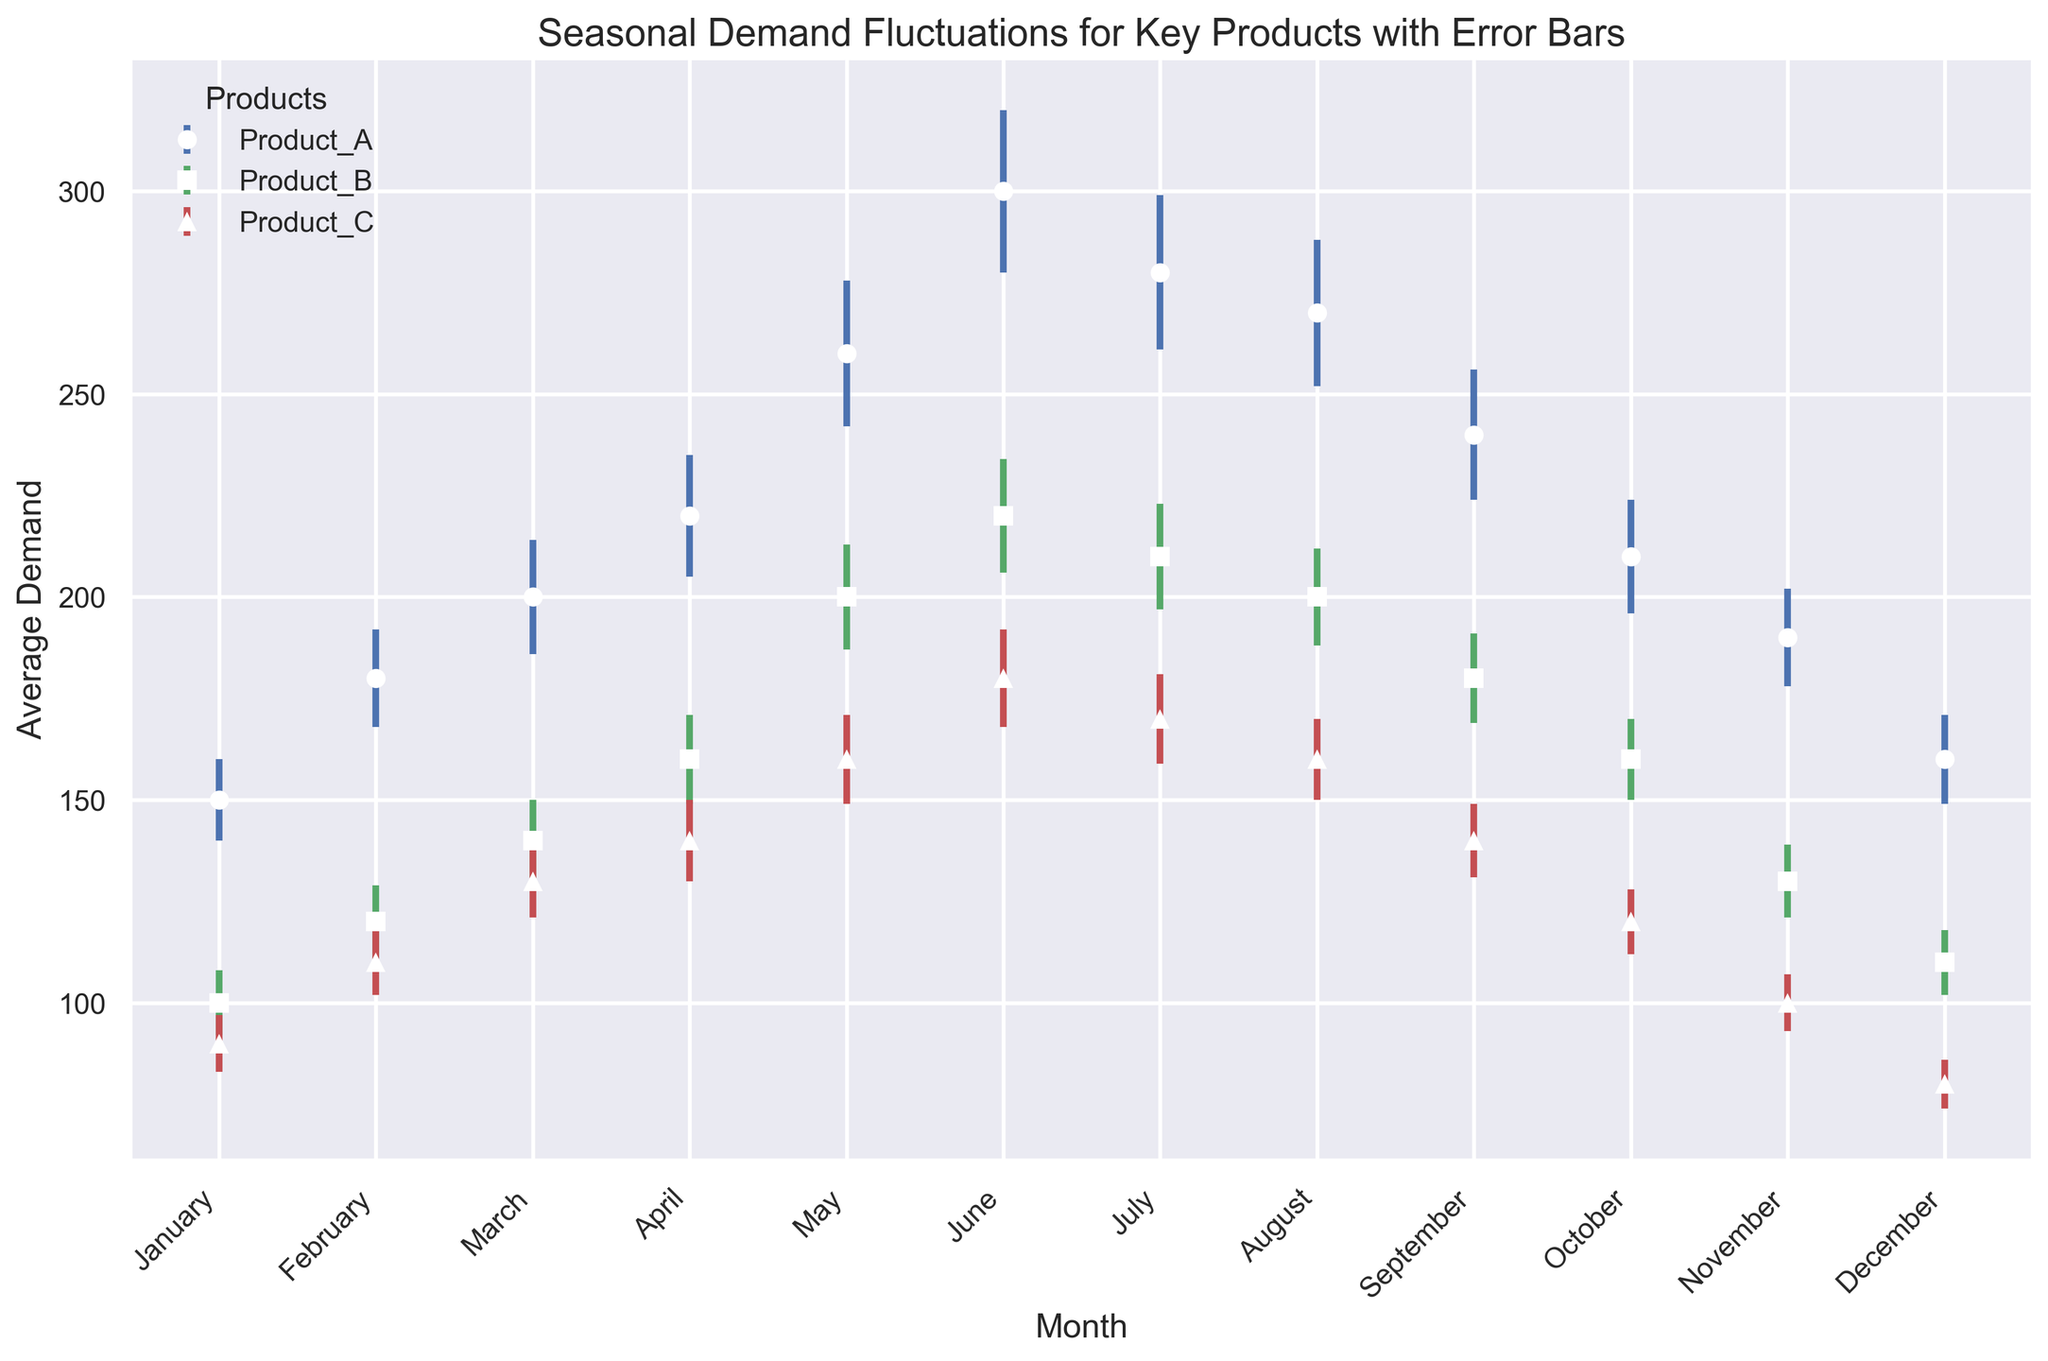Which product has the highest peak demand, and in which month does it occur? Observing the plot, Product_A peaks at 300 units in June, which is the highest among all products.
Answer: Product_A in June What is the difference in average demand between Product_B and Product_C in July? In July, Product_B has an average demand of 210 units, and Product_C has 170 units. The difference is 210 - 170 = 40 units.
Answer: 40 units Between which two consecutive months does Product_A show the largest decrease in demand? Between June and July, Product_A's demand decreases from 300 to 280 units, a drop of 20 units, which is the largest observed decrease.
Answer: June to July Which product shows the most consistent demand throughout the year, based on visually smallest error bars? Visually, Product_C has the smallest error bars throughout most months, indicating consistent demand.
Answer: Product_C In which month does Product_B have the lowest average demand, and what is it? Observing the plot, Product_B has the lowest demand of 100 units in January.
Answer: January with 100 units What is the average demand for Product_A over the entire year? Sum the average demand for each month for Product_A: (150 + 180 + 200 + 220 + 260 + 300 + 280 + 270 + 240 + 210 + 190 + 160) = 2660. Then divide by 12: 2660 / 12 = 221.67 units.
Answer: 221.67 units How does the demand for Product_C in December compare visually with the demand in January? In December, Product_C has a demand of 80 units, which is lower than its demand of 90 units in January.
Answer: Demand in December is lower than in January Comparing Products A and B, which one has a higher demand in May? By how much? In May, Product_A has a demand of 260 units, while Product_B has 200 units. The difference is 260 - 200 = 60 units.
Answer: Product_A by 60 units What is the trend in demand for Product_B from June to November? From June to November, Product_B's demand decreases from 220 units to 130 units, indicating a downward trend.
Answer: Downward trend Between April and August, which product's demand fluctuates the most based on average and standard error values? From April to August, Product_A shows the most fluctuation as it increases from 220 units to 270 units and has larger error bars, indicating greater variance.
Answer: Product_A 